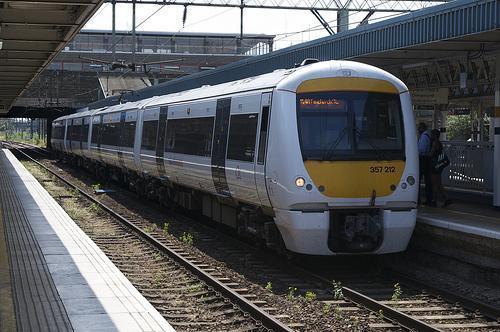How many train tracks have a train on them?
Give a very brief answer. 1. 